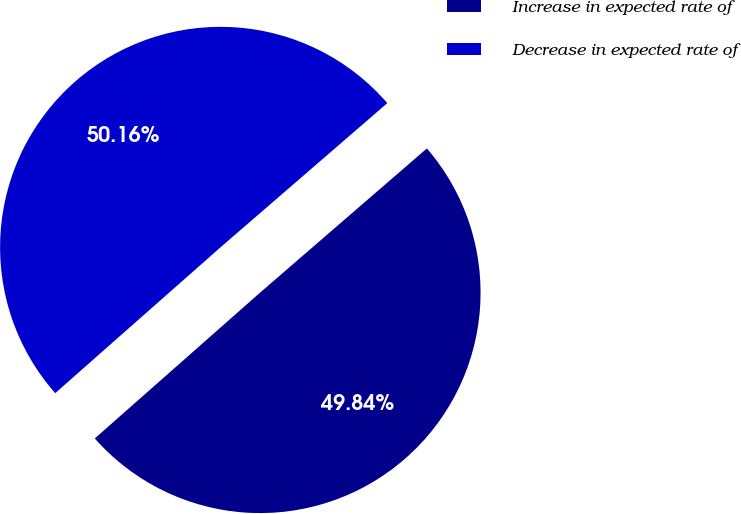Convert chart to OTSL. <chart><loc_0><loc_0><loc_500><loc_500><pie_chart><fcel>Increase in expected rate of<fcel>Decrease in expected rate of<nl><fcel>49.84%<fcel>50.16%<nl></chart> 